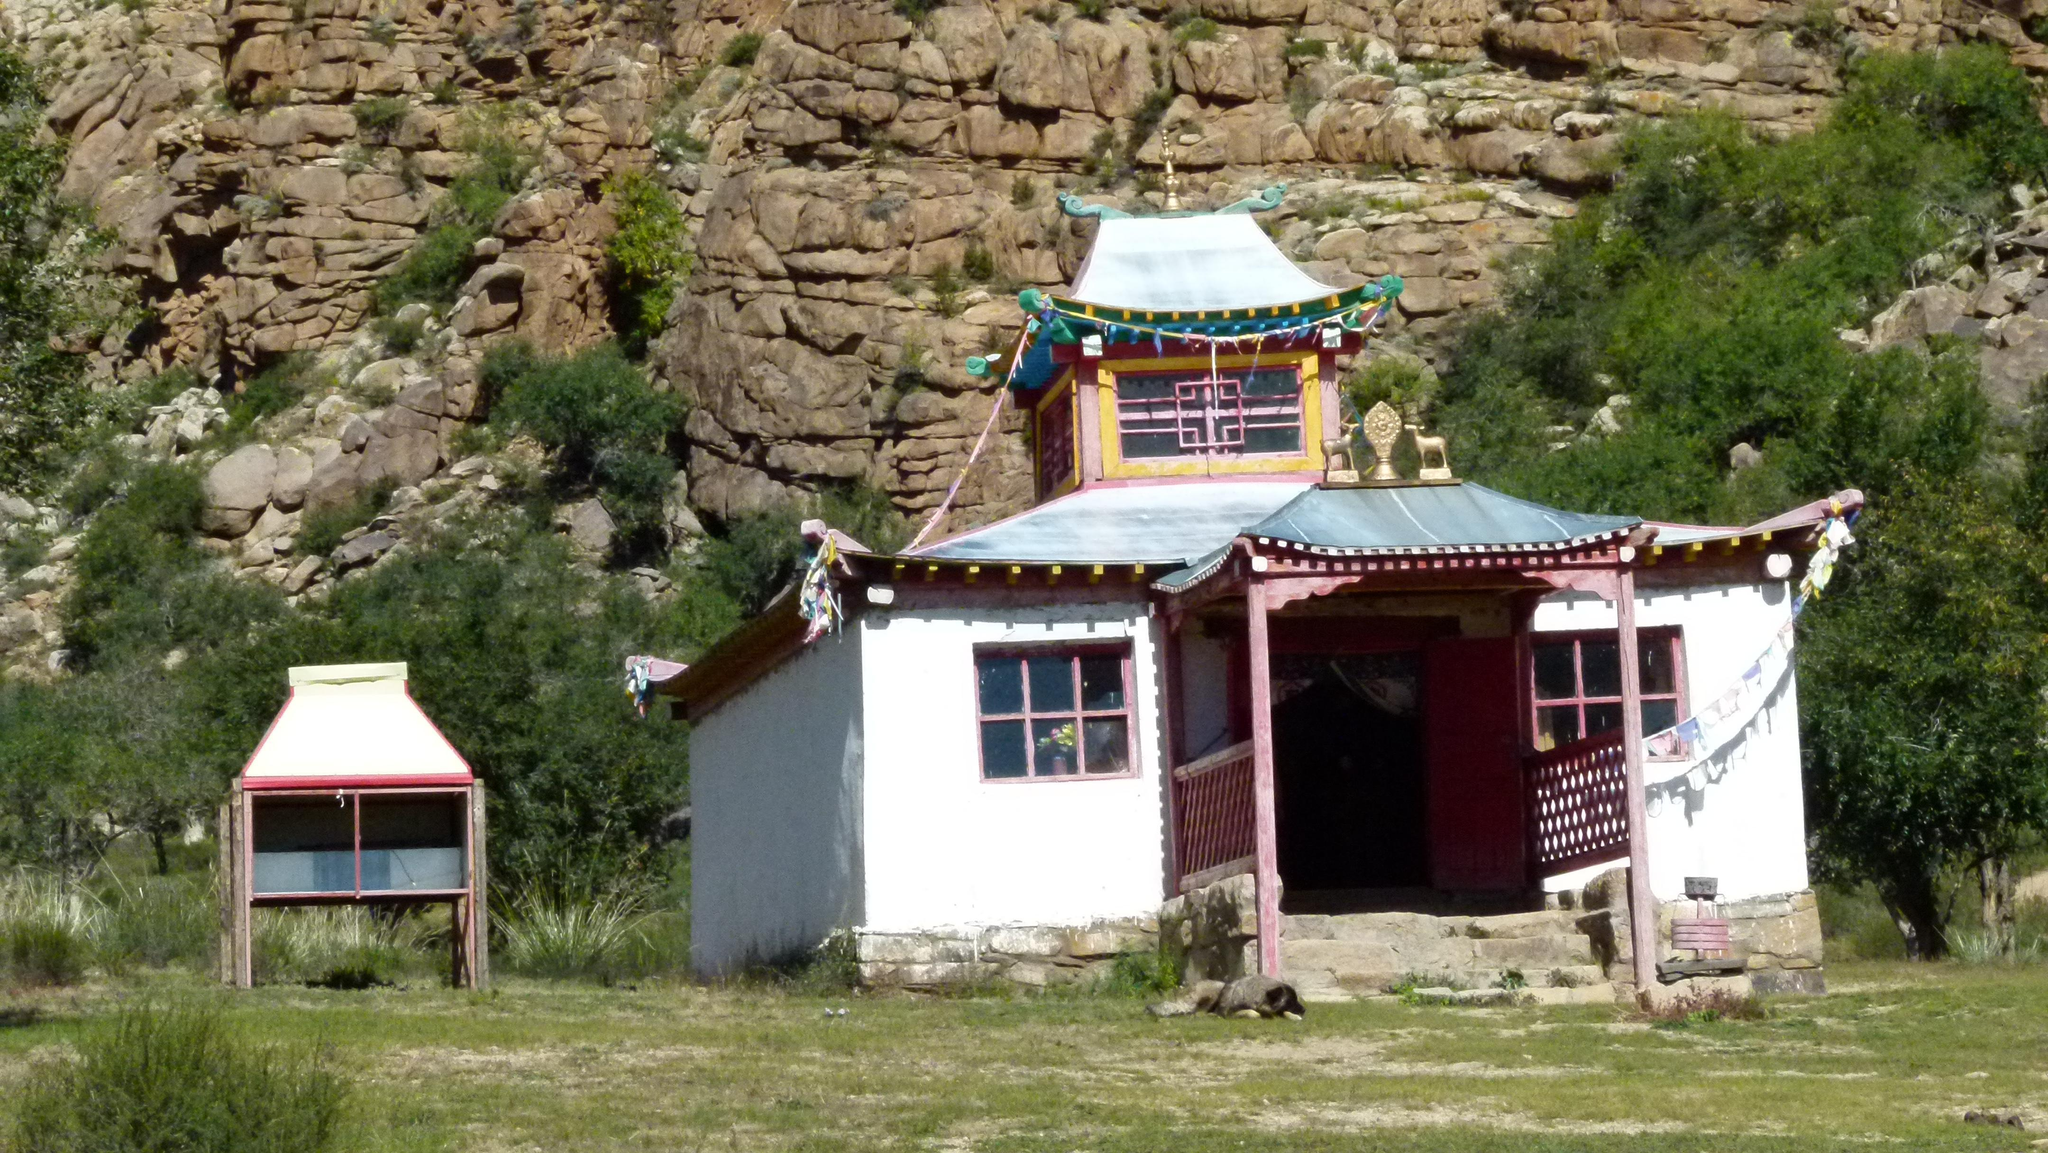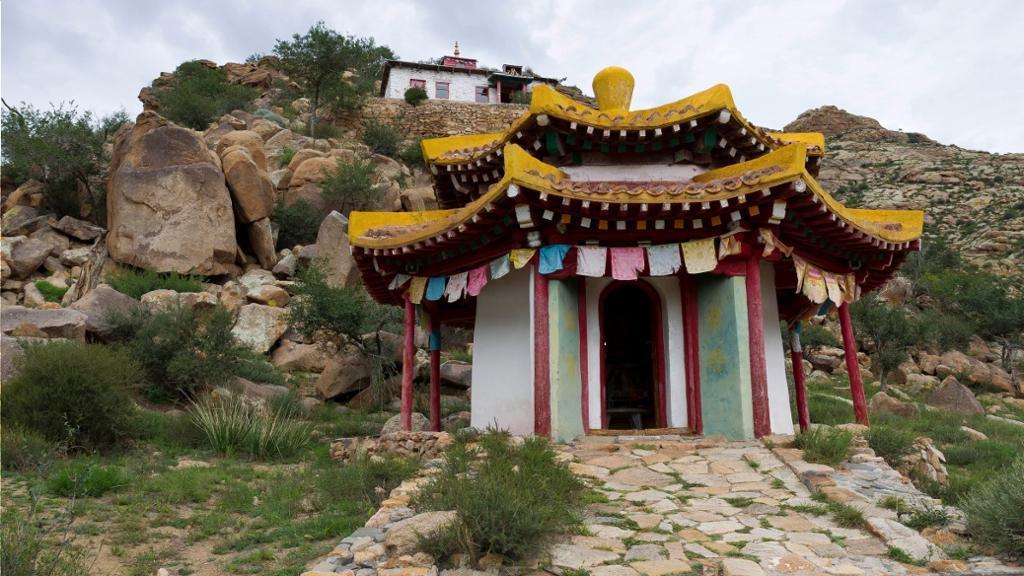The first image is the image on the left, the second image is the image on the right. Analyze the images presented: Is the assertion "One of the buildings has gold trimming on the roof." valid? Answer yes or no. Yes. The first image is the image on the left, the second image is the image on the right. Given the left and right images, does the statement "An image shows a structure with a yellow trimmed roof and a bulb-like yellow topper." hold true? Answer yes or no. Yes. 